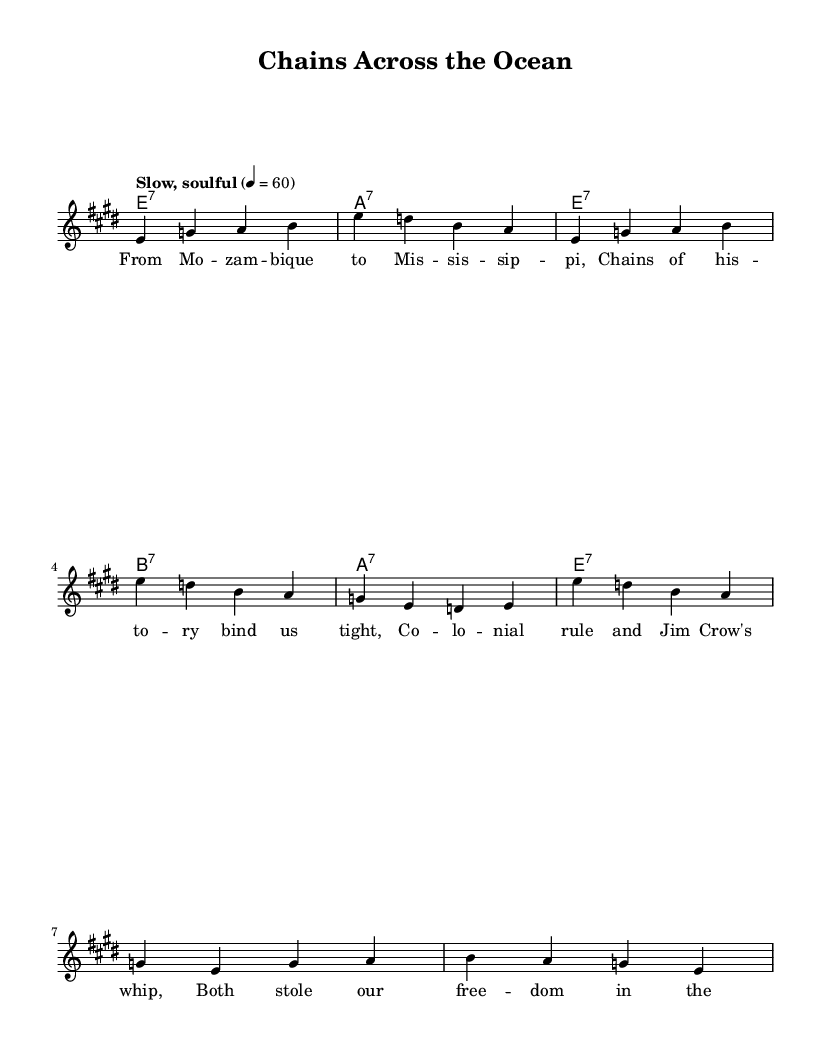What is the key signature of this music? The key signature is E major, as indicated by the two sharps (F# and C#) in the staff.
Answer: E major What is the time signature of this piece? The time signature is 4/4, which means there are four beats in each measure and the quarter note gets one beat.
Answer: 4/4 What tempo is indicated for this music? The tempo marking "Slow, soulful" implies a leisurely pace, and the specified metronome mark of 60 indicates that there are 60 beats per minute.
Answer: Slow, soulful How many measures are in the verse? The verse consists of eight measures, as counted from the notation before the chorus begins.
Answer: Eight What type of chords are used in the harmonies? The harmonies indicate seventh chords (7), specifically E7, A7, and B7, as shown in the chord names.
Answer: Seventh chords What do the lyrics primarily address? The lyrics address shared experiences of oppression, linking historical elements from both colonial Africa and the American South.
Answer: Oppression How does the structure of this piece reflect typical Blues music? The structure features a call-and-response format, with a melody and a repeating chorus, which is characteristic of Blues music.
Answer: Call-and-response 